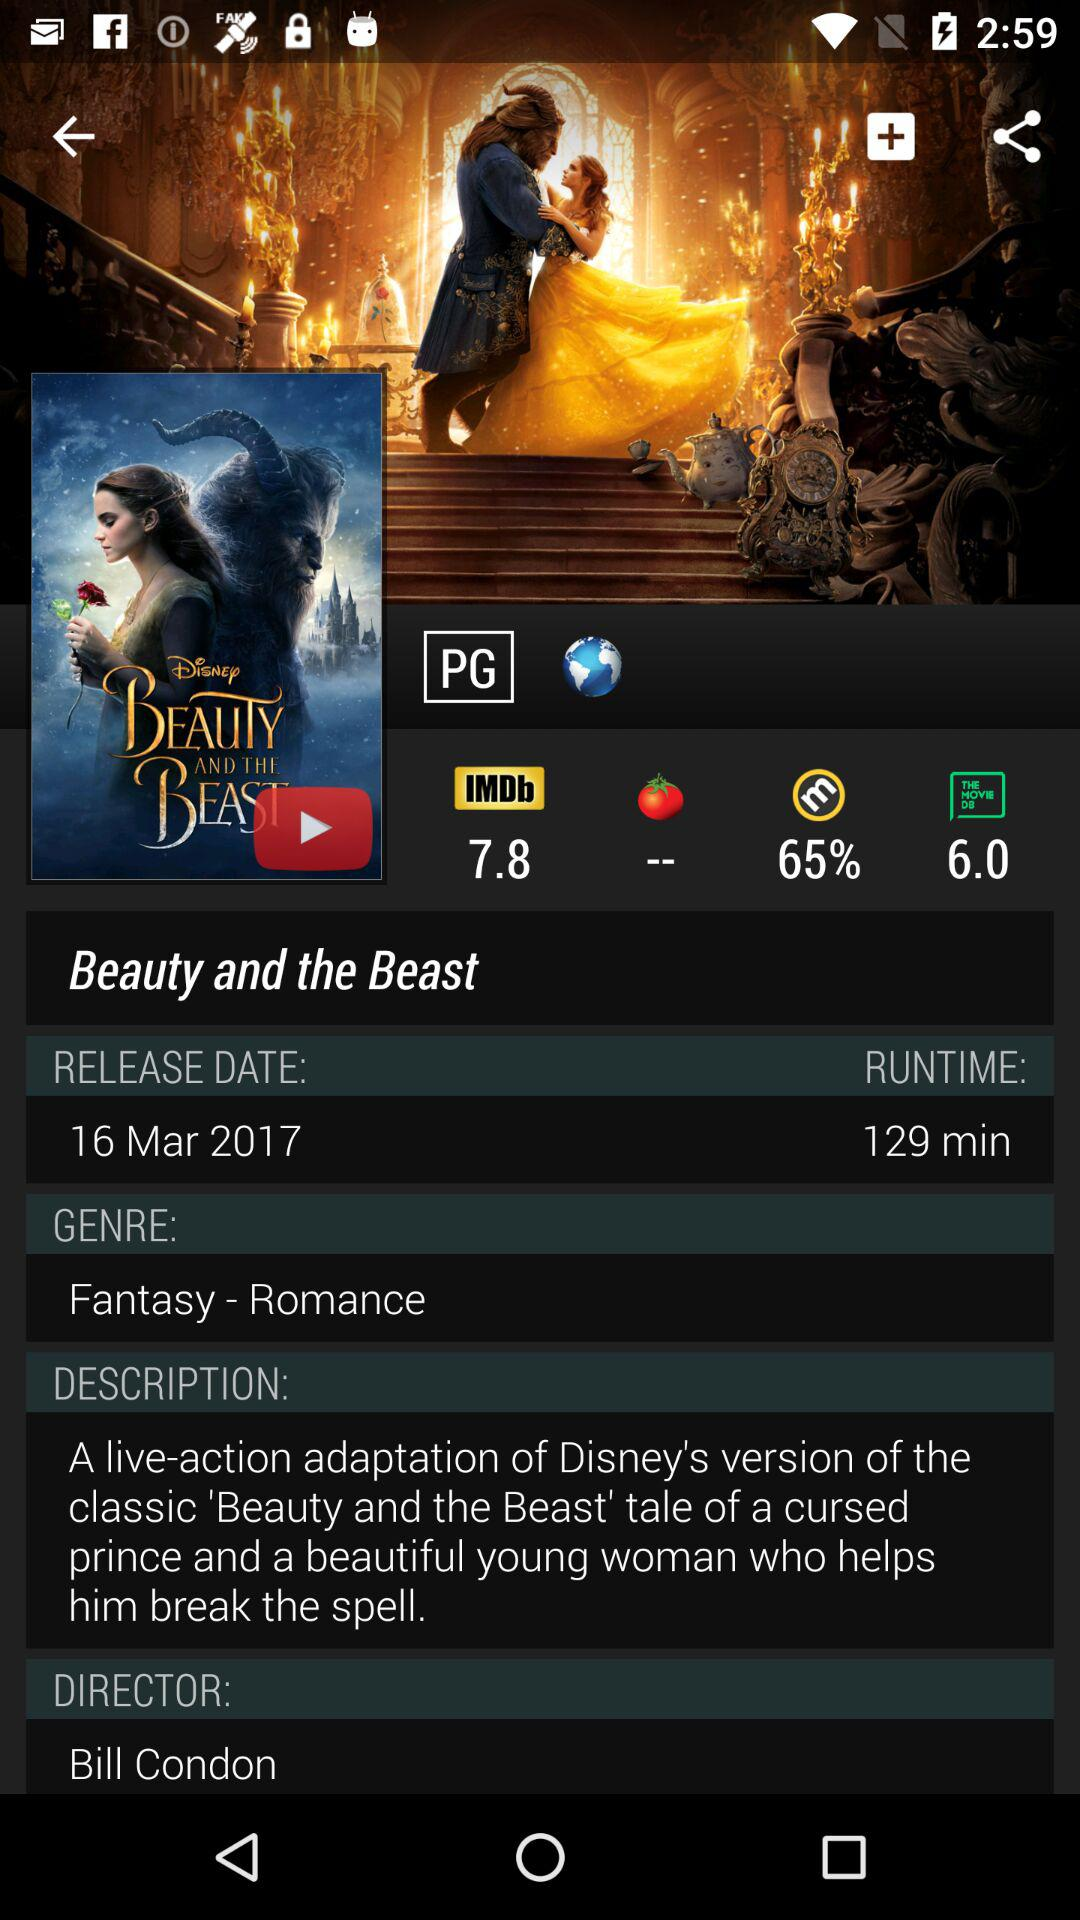What is the release date of "Beauty and the Beast"? The release date is March 16, 2017. 